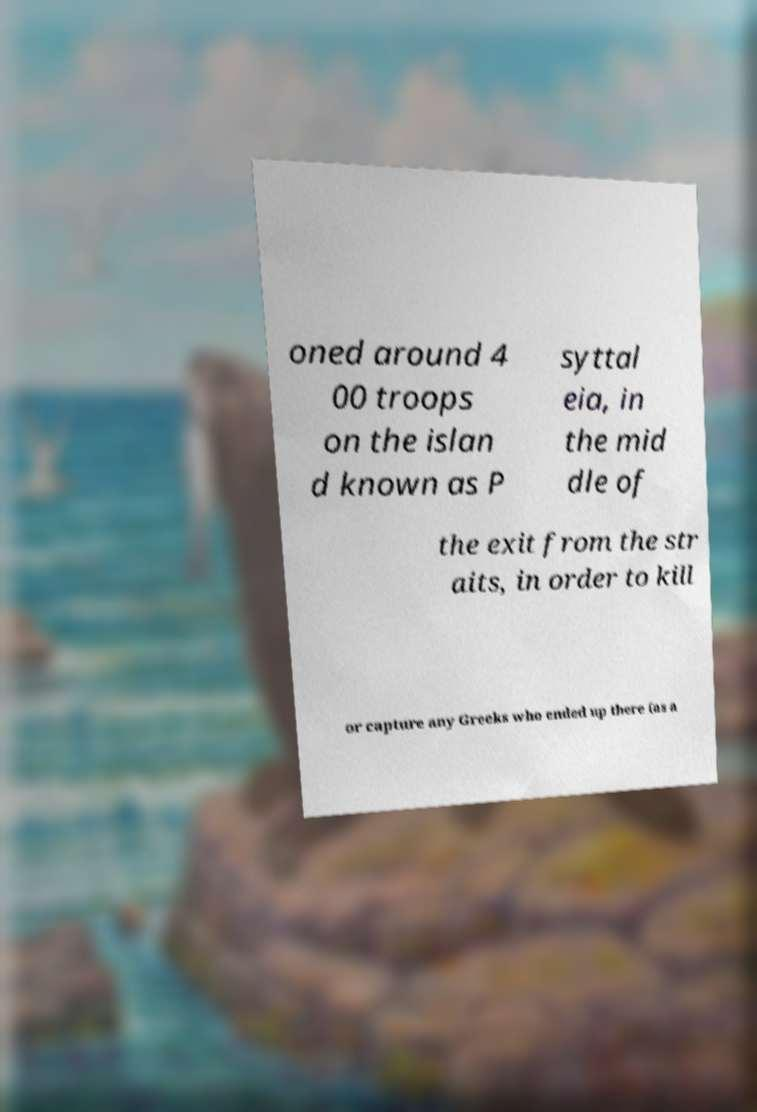Can you read and provide the text displayed in the image?This photo seems to have some interesting text. Can you extract and type it out for me? oned around 4 00 troops on the islan d known as P syttal eia, in the mid dle of the exit from the str aits, in order to kill or capture any Greeks who ended up there (as a 